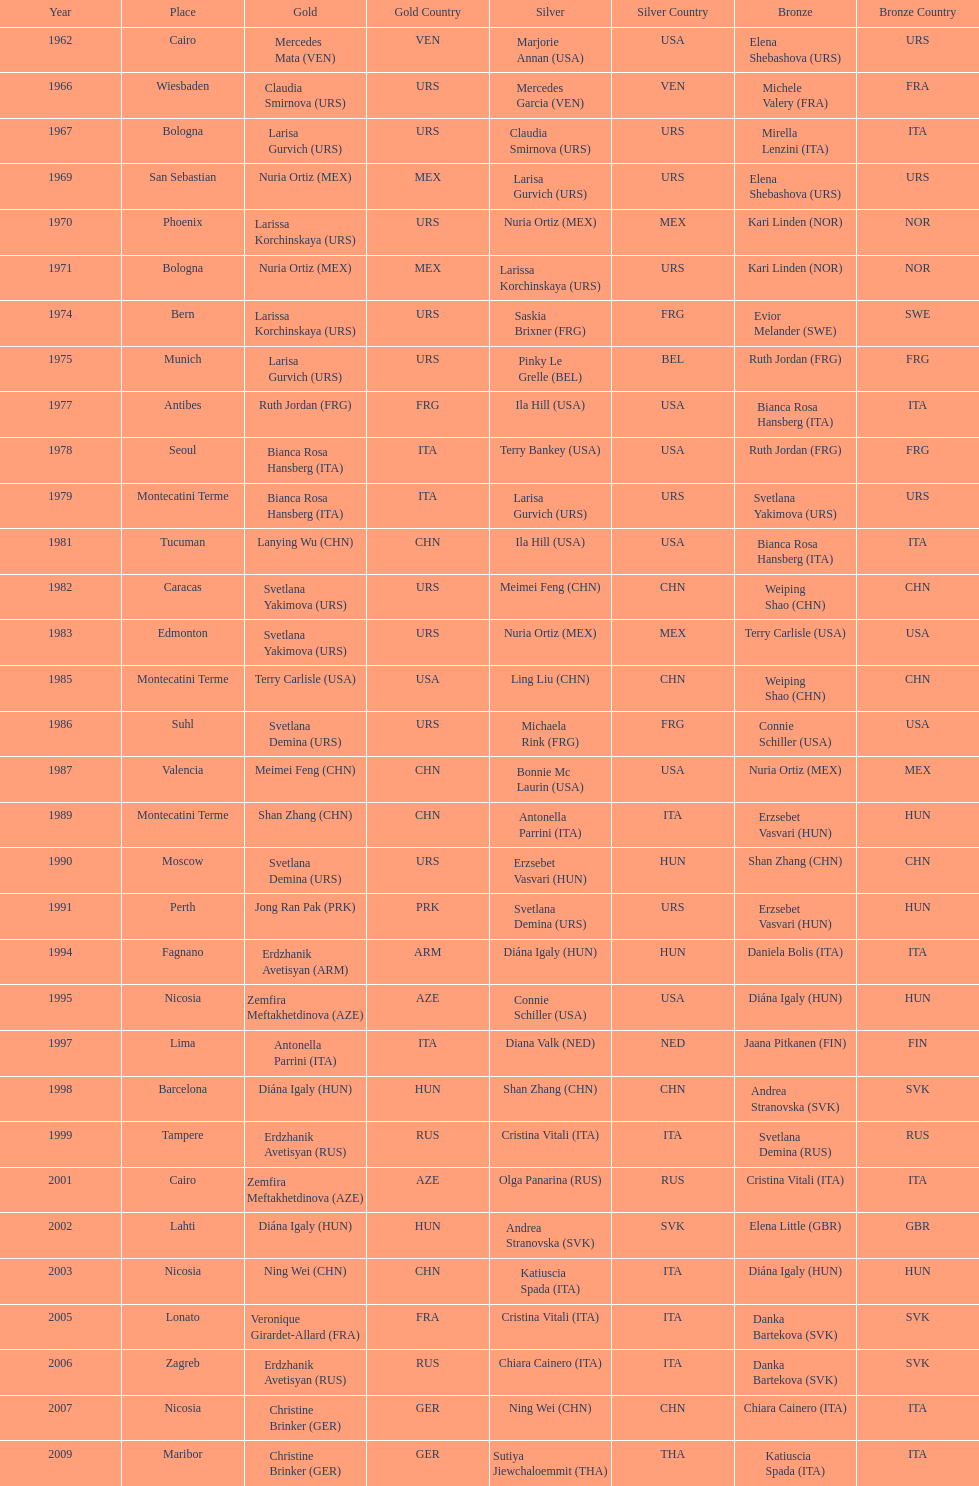What is the total amount of winnings for the united states in gold, silver and bronze? 9. 